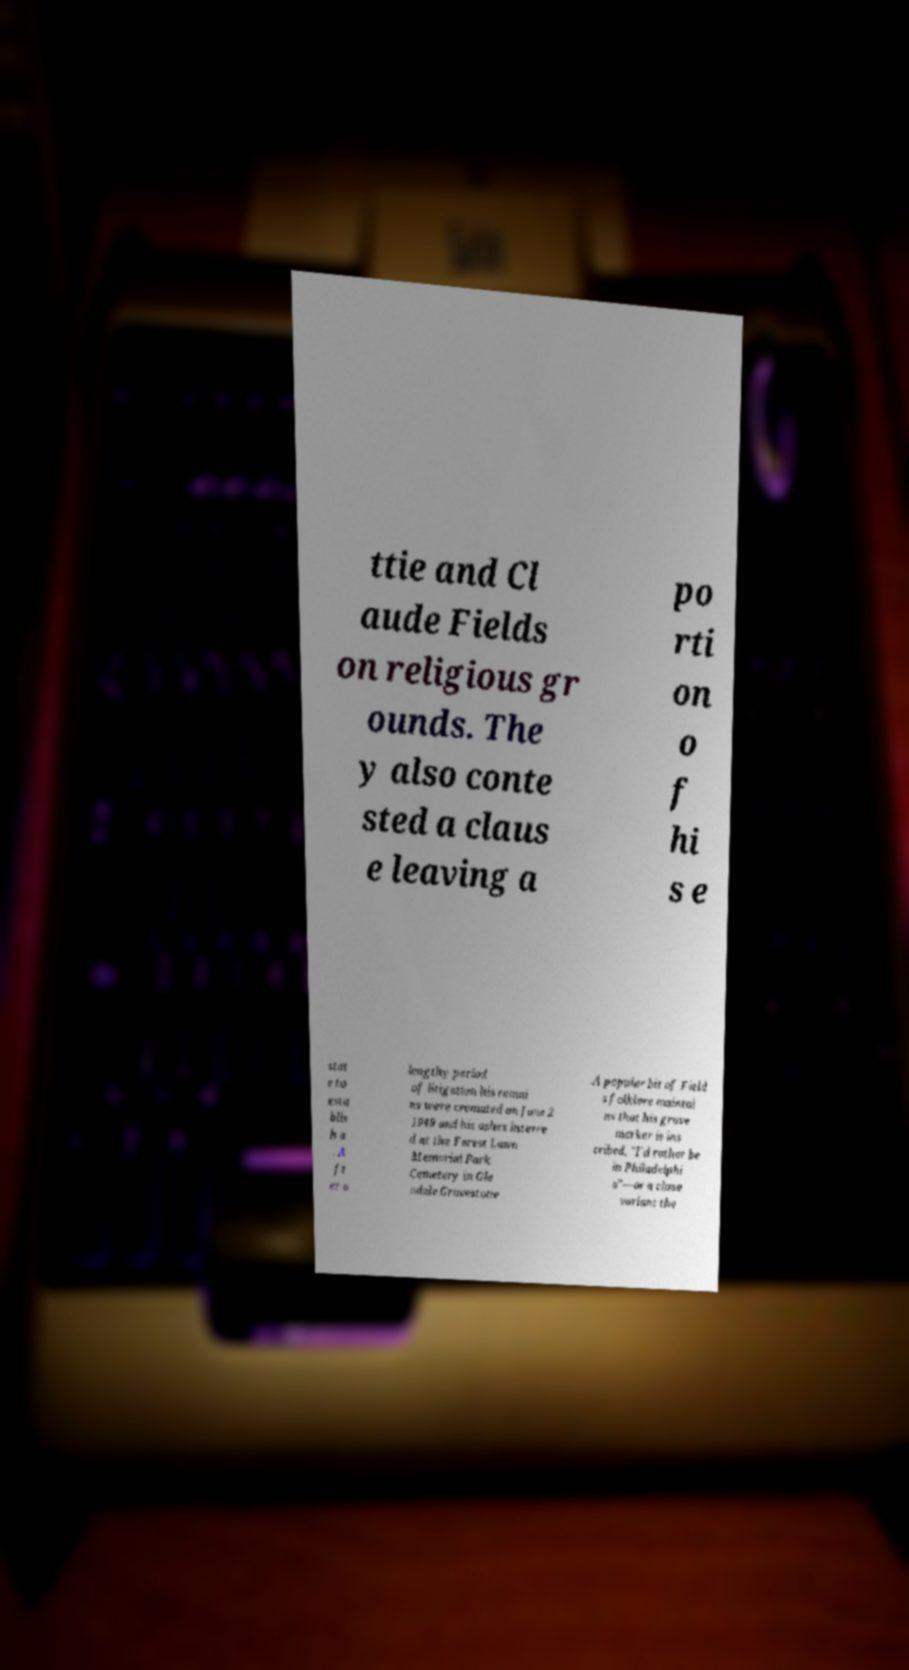For documentation purposes, I need the text within this image transcribed. Could you provide that? ttie and Cl aude Fields on religious gr ounds. The y also conte sted a claus e leaving a po rti on o f hi s e stat e to esta blis h a . A ft er a lengthy period of litigation his remai ns were cremated on June 2 1949 and his ashes interre d at the Forest Lawn Memorial Park Cemetery in Gle ndale.Gravestone .A popular bit of Field s folklore maintai ns that his grave marker is ins cribed, "I'd rather be in Philadelphi a"—or a close variant the 